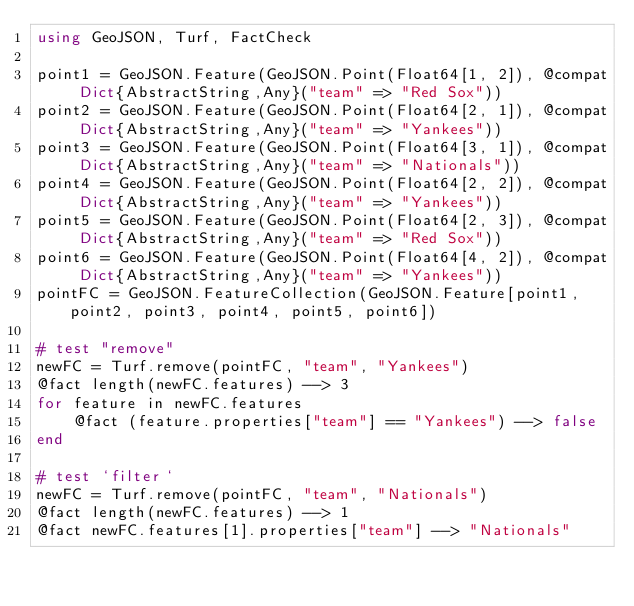Convert code to text. <code><loc_0><loc_0><loc_500><loc_500><_Julia_>using GeoJSON, Turf, FactCheck

point1 = GeoJSON.Feature(GeoJSON.Point(Float64[1, 2]), @compat Dict{AbstractString,Any}("team" => "Red Sox"))
point2 = GeoJSON.Feature(GeoJSON.Point(Float64[2, 1]), @compat Dict{AbstractString,Any}("team" => "Yankees"))
point3 = GeoJSON.Feature(GeoJSON.Point(Float64[3, 1]), @compat Dict{AbstractString,Any}("team" => "Nationals"))
point4 = GeoJSON.Feature(GeoJSON.Point(Float64[2, 2]), @compat Dict{AbstractString,Any}("team" => "Yankees"))
point5 = GeoJSON.Feature(GeoJSON.Point(Float64[2, 3]), @compat Dict{AbstractString,Any}("team" => "Red Sox"))
point6 = GeoJSON.Feature(GeoJSON.Point(Float64[4, 2]), @compat Dict{AbstractString,Any}("team" => "Yankees"))
pointFC = GeoJSON.FeatureCollection(GeoJSON.Feature[point1, point2, point3, point4, point5, point6])

# test "remove"
newFC = Turf.remove(pointFC, "team", "Yankees")
@fact length(newFC.features) --> 3
for feature in newFC.features
    @fact (feature.properties["team"] == "Yankees") --> false
end

# test `filter`
newFC = Turf.remove(pointFC, "team", "Nationals")
@fact length(newFC.features) --> 1
@fact newFC.features[1].properties["team"] --> "Nationals"
</code> 